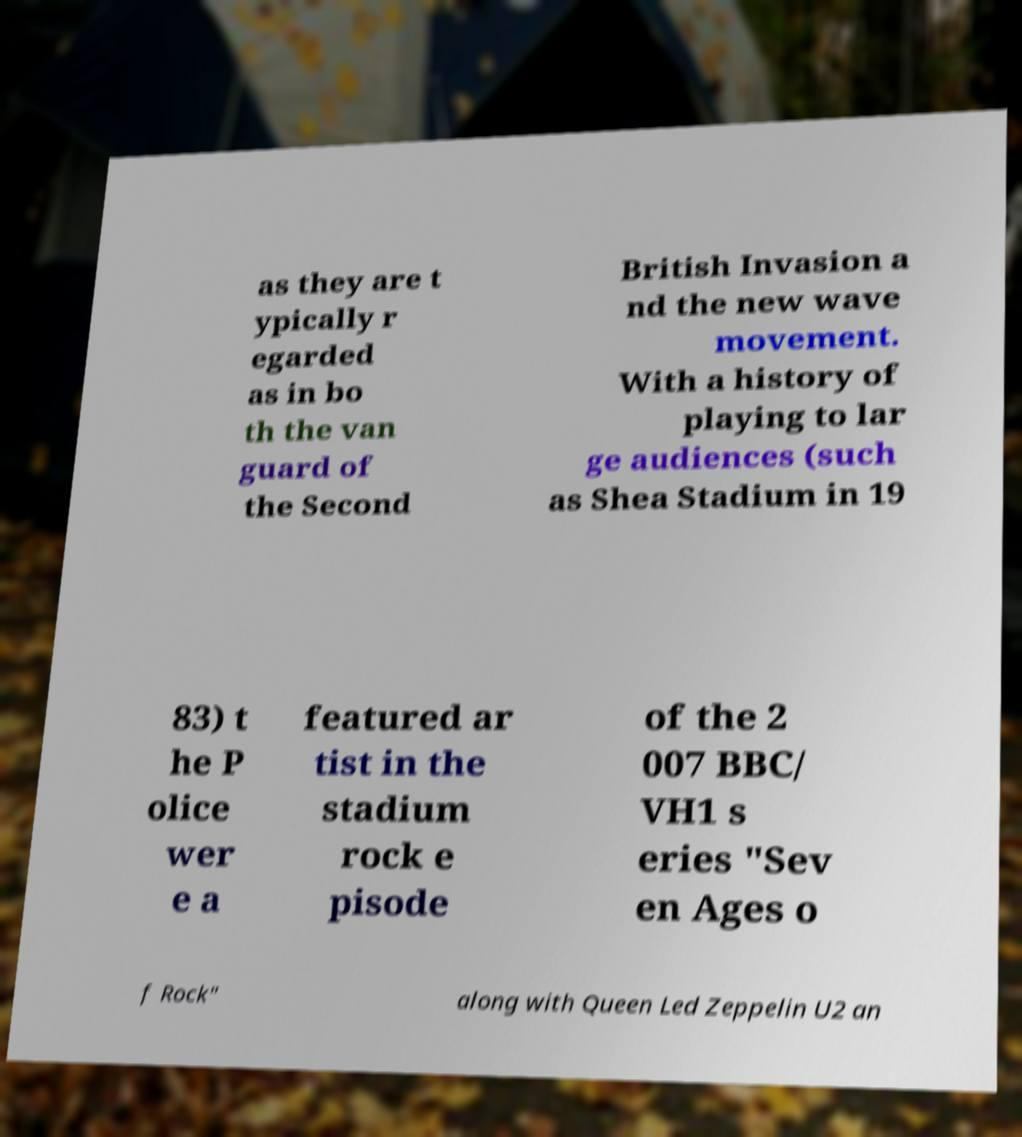Please read and relay the text visible in this image. What does it say? as they are t ypically r egarded as in bo th the van guard of the Second British Invasion a nd the new wave movement. With a history of playing to lar ge audiences (such as Shea Stadium in 19 83) t he P olice wer e a featured ar tist in the stadium rock e pisode of the 2 007 BBC/ VH1 s eries "Sev en Ages o f Rock" along with Queen Led Zeppelin U2 an 